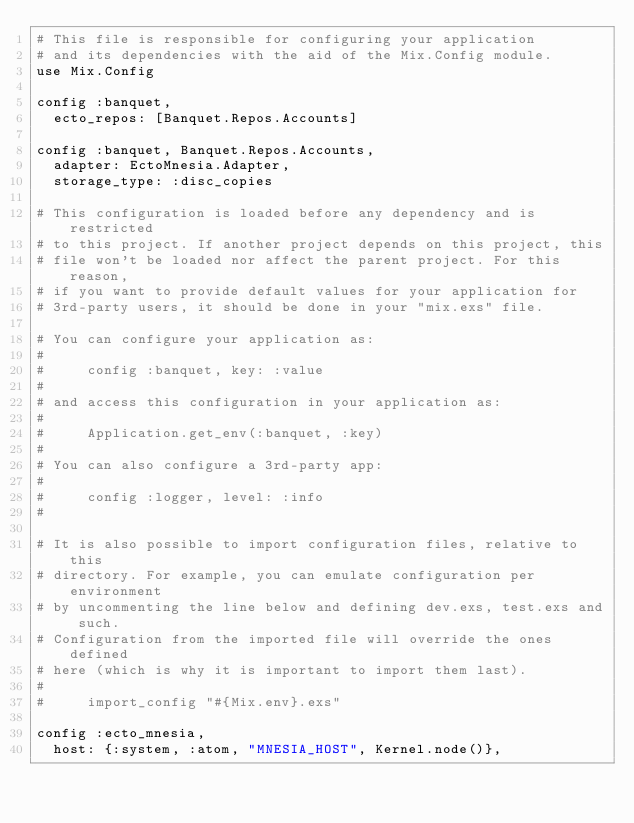Convert code to text. <code><loc_0><loc_0><loc_500><loc_500><_Elixir_># This file is responsible for configuring your application
# and its dependencies with the aid of the Mix.Config module.
use Mix.Config

config :banquet,
  ecto_repos: [Banquet.Repos.Accounts]

config :banquet, Banquet.Repos.Accounts,
  adapter: EctoMnesia.Adapter,
  storage_type: :disc_copies

# This configuration is loaded before any dependency and is restricted
# to this project. If another project depends on this project, this
# file won't be loaded nor affect the parent project. For this reason,
# if you want to provide default values for your application for
# 3rd-party users, it should be done in your "mix.exs" file.

# You can configure your application as:
#
#     config :banquet, key: :value
#
# and access this configuration in your application as:
#
#     Application.get_env(:banquet, :key)
#
# You can also configure a 3rd-party app:
#
#     config :logger, level: :info
#

# It is also possible to import configuration files, relative to this
# directory. For example, you can emulate configuration per environment
# by uncommenting the line below and defining dev.exs, test.exs and such.
# Configuration from the imported file will override the ones defined
# here (which is why it is important to import them last).
#
#     import_config "#{Mix.env}.exs"

config :ecto_mnesia,
  host: {:system, :atom, "MNESIA_HOST", Kernel.node()},</code> 